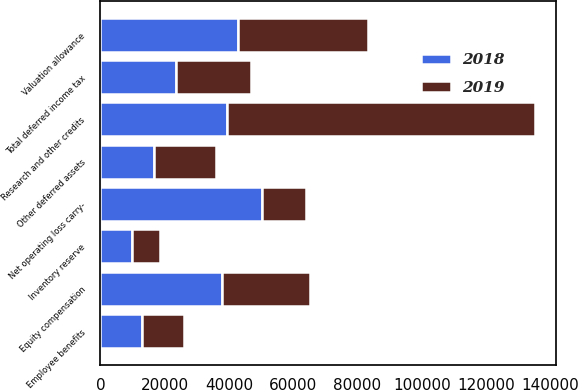Convert chart. <chart><loc_0><loc_0><loc_500><loc_500><stacked_bar_chart><ecel><fcel>Inventory reserve<fcel>Equity compensation<fcel>Net operating loss carry-<fcel>Research and other credits<fcel>Employee benefits<fcel>Other deferred assets<fcel>Total deferred income tax<fcel>Valuation allowance<nl><fcel>2019<fcel>8588<fcel>27380<fcel>13744<fcel>95640<fcel>13070<fcel>19457<fcel>23418.5<fcel>40433<nl><fcel>2018<fcel>9894<fcel>37724<fcel>50128<fcel>39513<fcel>12842<fcel>16620<fcel>23418.5<fcel>42787<nl></chart> 